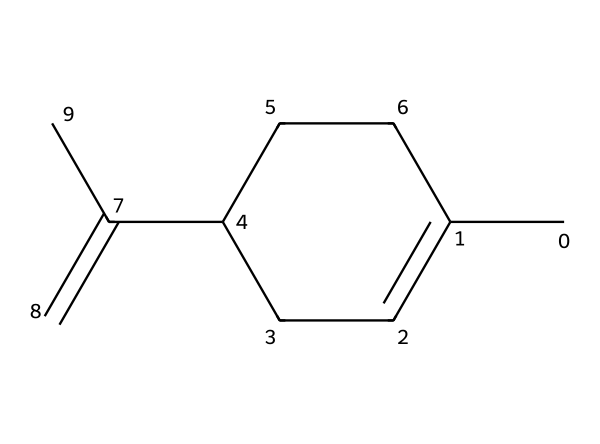how many carbon atoms are in limonene? Counting the carbon atoms in the given SMILES representation (CC1=CCC(CC1)C(=C)C) shows there are 10 carbon (C) atoms overall.
Answer: 10 how many double bonds are present in the structure of limonene? Analyzing the SMILES representation, there are two carbon-carbon double bonds indicated by the '=' signs in the structure.
Answer: 2 what is the primary functional group in limonene? The presence of the C=C (double bond) indicates that the primary functional group is an alkene.
Answer: alkene how many hydrogen atoms are attached to limonene? For every carbon atom, two hydrogens are typically bonded, but due to the double bonds and the cyclic structure, the total number of attached hydrogens is calculated to be 16.
Answer: 16 what type of molecule is limonene classified as? Limonene is classified based on its structure as a terpene, which is often characterized by its isoprene units.
Answer: terpene what kind of symmetry does limonene exhibit? Considering the branched and cyclic structure of limonene, it exhibits a certain type of symmetry known as dihedral symmetry, common to certain terpenes.
Answer: dihedral symmetry 